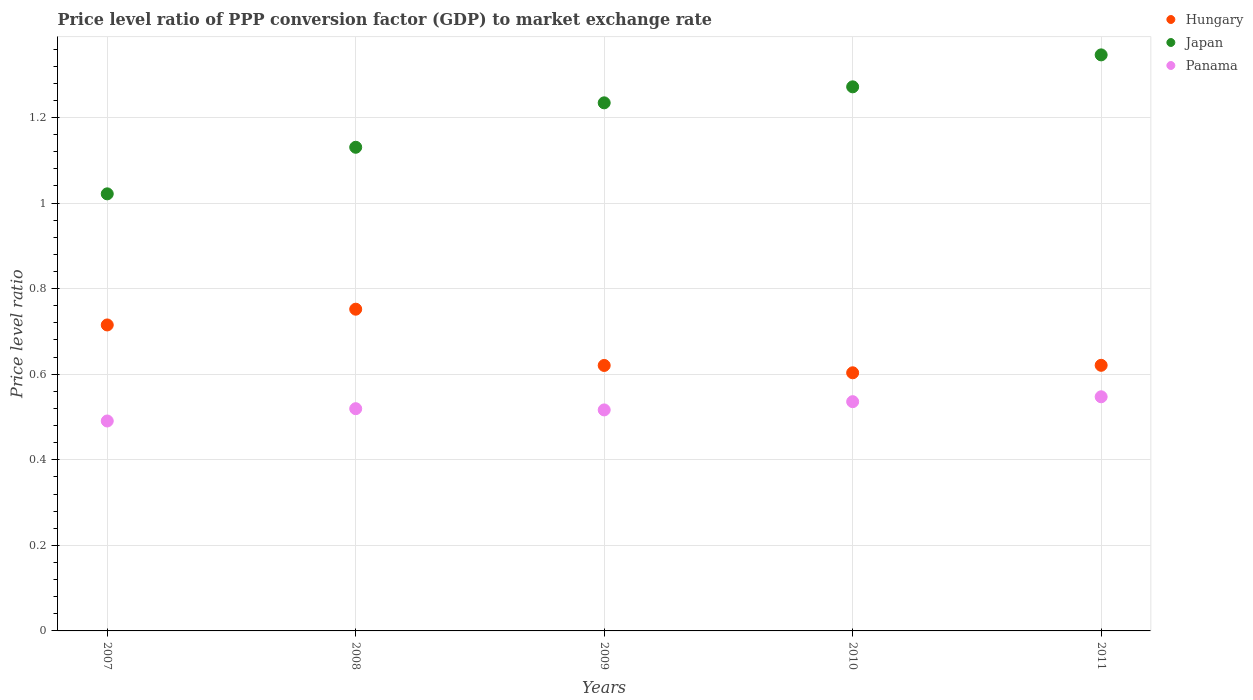What is the price level ratio in Panama in 2010?
Provide a short and direct response. 0.54. Across all years, what is the maximum price level ratio in Japan?
Offer a terse response. 1.35. Across all years, what is the minimum price level ratio in Panama?
Make the answer very short. 0.49. In which year was the price level ratio in Panama maximum?
Offer a very short reply. 2011. What is the total price level ratio in Panama in the graph?
Provide a short and direct response. 2.61. What is the difference between the price level ratio in Panama in 2007 and that in 2011?
Provide a short and direct response. -0.06. What is the difference between the price level ratio in Panama in 2011 and the price level ratio in Japan in 2008?
Make the answer very short. -0.58. What is the average price level ratio in Hungary per year?
Provide a short and direct response. 0.66. In the year 2010, what is the difference between the price level ratio in Panama and price level ratio in Japan?
Provide a short and direct response. -0.74. What is the ratio of the price level ratio in Panama in 2007 to that in 2009?
Provide a succinct answer. 0.95. What is the difference between the highest and the second highest price level ratio in Panama?
Make the answer very short. 0.01. What is the difference between the highest and the lowest price level ratio in Japan?
Offer a terse response. 0.32. Does the price level ratio in Panama monotonically increase over the years?
Ensure brevity in your answer.  No. How many dotlines are there?
Offer a terse response. 3. What is the difference between two consecutive major ticks on the Y-axis?
Ensure brevity in your answer.  0.2. Does the graph contain grids?
Provide a short and direct response. Yes. Where does the legend appear in the graph?
Your answer should be compact. Top right. How many legend labels are there?
Your answer should be compact. 3. How are the legend labels stacked?
Offer a terse response. Vertical. What is the title of the graph?
Keep it short and to the point. Price level ratio of PPP conversion factor (GDP) to market exchange rate. Does "Gabon" appear as one of the legend labels in the graph?
Offer a very short reply. No. What is the label or title of the X-axis?
Offer a terse response. Years. What is the label or title of the Y-axis?
Your answer should be very brief. Price level ratio. What is the Price level ratio of Hungary in 2007?
Ensure brevity in your answer.  0.72. What is the Price level ratio of Japan in 2007?
Make the answer very short. 1.02. What is the Price level ratio of Panama in 2007?
Make the answer very short. 0.49. What is the Price level ratio in Hungary in 2008?
Offer a terse response. 0.75. What is the Price level ratio of Japan in 2008?
Offer a very short reply. 1.13. What is the Price level ratio in Panama in 2008?
Give a very brief answer. 0.52. What is the Price level ratio of Hungary in 2009?
Provide a succinct answer. 0.62. What is the Price level ratio in Japan in 2009?
Your answer should be compact. 1.23. What is the Price level ratio in Panama in 2009?
Give a very brief answer. 0.52. What is the Price level ratio of Hungary in 2010?
Make the answer very short. 0.6. What is the Price level ratio of Japan in 2010?
Provide a succinct answer. 1.27. What is the Price level ratio of Panama in 2010?
Give a very brief answer. 0.54. What is the Price level ratio in Hungary in 2011?
Give a very brief answer. 0.62. What is the Price level ratio in Japan in 2011?
Your response must be concise. 1.35. What is the Price level ratio of Panama in 2011?
Make the answer very short. 0.55. Across all years, what is the maximum Price level ratio of Hungary?
Give a very brief answer. 0.75. Across all years, what is the maximum Price level ratio in Japan?
Offer a very short reply. 1.35. Across all years, what is the maximum Price level ratio of Panama?
Give a very brief answer. 0.55. Across all years, what is the minimum Price level ratio of Hungary?
Ensure brevity in your answer.  0.6. Across all years, what is the minimum Price level ratio of Japan?
Keep it short and to the point. 1.02. Across all years, what is the minimum Price level ratio of Panama?
Give a very brief answer. 0.49. What is the total Price level ratio of Hungary in the graph?
Make the answer very short. 3.31. What is the total Price level ratio in Japan in the graph?
Make the answer very short. 6. What is the total Price level ratio of Panama in the graph?
Offer a very short reply. 2.61. What is the difference between the Price level ratio of Hungary in 2007 and that in 2008?
Your response must be concise. -0.04. What is the difference between the Price level ratio of Japan in 2007 and that in 2008?
Offer a very short reply. -0.11. What is the difference between the Price level ratio in Panama in 2007 and that in 2008?
Provide a short and direct response. -0.03. What is the difference between the Price level ratio of Hungary in 2007 and that in 2009?
Provide a succinct answer. 0.09. What is the difference between the Price level ratio in Japan in 2007 and that in 2009?
Provide a short and direct response. -0.21. What is the difference between the Price level ratio of Panama in 2007 and that in 2009?
Your answer should be very brief. -0.03. What is the difference between the Price level ratio of Hungary in 2007 and that in 2010?
Your answer should be very brief. 0.11. What is the difference between the Price level ratio in Japan in 2007 and that in 2010?
Keep it short and to the point. -0.25. What is the difference between the Price level ratio of Panama in 2007 and that in 2010?
Your response must be concise. -0.05. What is the difference between the Price level ratio in Hungary in 2007 and that in 2011?
Your answer should be compact. 0.09. What is the difference between the Price level ratio in Japan in 2007 and that in 2011?
Offer a very short reply. -0.32. What is the difference between the Price level ratio of Panama in 2007 and that in 2011?
Provide a short and direct response. -0.06. What is the difference between the Price level ratio of Hungary in 2008 and that in 2009?
Make the answer very short. 0.13. What is the difference between the Price level ratio of Japan in 2008 and that in 2009?
Offer a terse response. -0.1. What is the difference between the Price level ratio of Panama in 2008 and that in 2009?
Provide a short and direct response. 0. What is the difference between the Price level ratio in Hungary in 2008 and that in 2010?
Keep it short and to the point. 0.15. What is the difference between the Price level ratio in Japan in 2008 and that in 2010?
Offer a very short reply. -0.14. What is the difference between the Price level ratio of Panama in 2008 and that in 2010?
Ensure brevity in your answer.  -0.02. What is the difference between the Price level ratio of Hungary in 2008 and that in 2011?
Your answer should be very brief. 0.13. What is the difference between the Price level ratio in Japan in 2008 and that in 2011?
Make the answer very short. -0.22. What is the difference between the Price level ratio in Panama in 2008 and that in 2011?
Your answer should be very brief. -0.03. What is the difference between the Price level ratio of Hungary in 2009 and that in 2010?
Your answer should be very brief. 0.02. What is the difference between the Price level ratio of Japan in 2009 and that in 2010?
Provide a short and direct response. -0.04. What is the difference between the Price level ratio of Panama in 2009 and that in 2010?
Provide a short and direct response. -0.02. What is the difference between the Price level ratio in Hungary in 2009 and that in 2011?
Provide a succinct answer. -0. What is the difference between the Price level ratio of Japan in 2009 and that in 2011?
Offer a very short reply. -0.11. What is the difference between the Price level ratio in Panama in 2009 and that in 2011?
Provide a succinct answer. -0.03. What is the difference between the Price level ratio in Hungary in 2010 and that in 2011?
Your answer should be compact. -0.02. What is the difference between the Price level ratio of Japan in 2010 and that in 2011?
Your answer should be very brief. -0.07. What is the difference between the Price level ratio of Panama in 2010 and that in 2011?
Your response must be concise. -0.01. What is the difference between the Price level ratio in Hungary in 2007 and the Price level ratio in Japan in 2008?
Offer a very short reply. -0.42. What is the difference between the Price level ratio in Hungary in 2007 and the Price level ratio in Panama in 2008?
Offer a very short reply. 0.2. What is the difference between the Price level ratio of Japan in 2007 and the Price level ratio of Panama in 2008?
Offer a terse response. 0.5. What is the difference between the Price level ratio in Hungary in 2007 and the Price level ratio in Japan in 2009?
Keep it short and to the point. -0.52. What is the difference between the Price level ratio in Hungary in 2007 and the Price level ratio in Panama in 2009?
Your response must be concise. 0.2. What is the difference between the Price level ratio of Japan in 2007 and the Price level ratio of Panama in 2009?
Provide a short and direct response. 0.51. What is the difference between the Price level ratio of Hungary in 2007 and the Price level ratio of Japan in 2010?
Offer a very short reply. -0.56. What is the difference between the Price level ratio of Hungary in 2007 and the Price level ratio of Panama in 2010?
Your answer should be compact. 0.18. What is the difference between the Price level ratio of Japan in 2007 and the Price level ratio of Panama in 2010?
Provide a succinct answer. 0.49. What is the difference between the Price level ratio of Hungary in 2007 and the Price level ratio of Japan in 2011?
Keep it short and to the point. -0.63. What is the difference between the Price level ratio in Hungary in 2007 and the Price level ratio in Panama in 2011?
Make the answer very short. 0.17. What is the difference between the Price level ratio of Japan in 2007 and the Price level ratio of Panama in 2011?
Offer a terse response. 0.47. What is the difference between the Price level ratio of Hungary in 2008 and the Price level ratio of Japan in 2009?
Offer a very short reply. -0.48. What is the difference between the Price level ratio of Hungary in 2008 and the Price level ratio of Panama in 2009?
Offer a terse response. 0.24. What is the difference between the Price level ratio in Japan in 2008 and the Price level ratio in Panama in 2009?
Make the answer very short. 0.61. What is the difference between the Price level ratio in Hungary in 2008 and the Price level ratio in Japan in 2010?
Provide a short and direct response. -0.52. What is the difference between the Price level ratio in Hungary in 2008 and the Price level ratio in Panama in 2010?
Keep it short and to the point. 0.22. What is the difference between the Price level ratio in Japan in 2008 and the Price level ratio in Panama in 2010?
Your answer should be compact. 0.59. What is the difference between the Price level ratio in Hungary in 2008 and the Price level ratio in Japan in 2011?
Keep it short and to the point. -0.59. What is the difference between the Price level ratio in Hungary in 2008 and the Price level ratio in Panama in 2011?
Offer a very short reply. 0.2. What is the difference between the Price level ratio in Japan in 2008 and the Price level ratio in Panama in 2011?
Your response must be concise. 0.58. What is the difference between the Price level ratio of Hungary in 2009 and the Price level ratio of Japan in 2010?
Keep it short and to the point. -0.65. What is the difference between the Price level ratio of Hungary in 2009 and the Price level ratio of Panama in 2010?
Make the answer very short. 0.08. What is the difference between the Price level ratio of Japan in 2009 and the Price level ratio of Panama in 2010?
Your response must be concise. 0.7. What is the difference between the Price level ratio in Hungary in 2009 and the Price level ratio in Japan in 2011?
Offer a terse response. -0.73. What is the difference between the Price level ratio in Hungary in 2009 and the Price level ratio in Panama in 2011?
Offer a very short reply. 0.07. What is the difference between the Price level ratio of Japan in 2009 and the Price level ratio of Panama in 2011?
Your answer should be very brief. 0.69. What is the difference between the Price level ratio in Hungary in 2010 and the Price level ratio in Japan in 2011?
Ensure brevity in your answer.  -0.74. What is the difference between the Price level ratio in Hungary in 2010 and the Price level ratio in Panama in 2011?
Your answer should be very brief. 0.06. What is the difference between the Price level ratio of Japan in 2010 and the Price level ratio of Panama in 2011?
Keep it short and to the point. 0.72. What is the average Price level ratio of Hungary per year?
Make the answer very short. 0.66. What is the average Price level ratio in Japan per year?
Provide a succinct answer. 1.2. What is the average Price level ratio in Panama per year?
Your answer should be very brief. 0.52. In the year 2007, what is the difference between the Price level ratio in Hungary and Price level ratio in Japan?
Offer a very short reply. -0.31. In the year 2007, what is the difference between the Price level ratio of Hungary and Price level ratio of Panama?
Provide a short and direct response. 0.22. In the year 2007, what is the difference between the Price level ratio in Japan and Price level ratio in Panama?
Offer a very short reply. 0.53. In the year 2008, what is the difference between the Price level ratio in Hungary and Price level ratio in Japan?
Your answer should be compact. -0.38. In the year 2008, what is the difference between the Price level ratio in Hungary and Price level ratio in Panama?
Your answer should be compact. 0.23. In the year 2008, what is the difference between the Price level ratio in Japan and Price level ratio in Panama?
Ensure brevity in your answer.  0.61. In the year 2009, what is the difference between the Price level ratio of Hungary and Price level ratio of Japan?
Offer a terse response. -0.61. In the year 2009, what is the difference between the Price level ratio of Hungary and Price level ratio of Panama?
Provide a short and direct response. 0.1. In the year 2009, what is the difference between the Price level ratio in Japan and Price level ratio in Panama?
Provide a short and direct response. 0.72. In the year 2010, what is the difference between the Price level ratio in Hungary and Price level ratio in Japan?
Provide a short and direct response. -0.67. In the year 2010, what is the difference between the Price level ratio in Hungary and Price level ratio in Panama?
Offer a terse response. 0.07. In the year 2010, what is the difference between the Price level ratio of Japan and Price level ratio of Panama?
Provide a short and direct response. 0.74. In the year 2011, what is the difference between the Price level ratio in Hungary and Price level ratio in Japan?
Make the answer very short. -0.73. In the year 2011, what is the difference between the Price level ratio of Hungary and Price level ratio of Panama?
Your response must be concise. 0.07. In the year 2011, what is the difference between the Price level ratio in Japan and Price level ratio in Panama?
Provide a succinct answer. 0.8. What is the ratio of the Price level ratio of Hungary in 2007 to that in 2008?
Your answer should be compact. 0.95. What is the ratio of the Price level ratio in Japan in 2007 to that in 2008?
Your response must be concise. 0.9. What is the ratio of the Price level ratio in Panama in 2007 to that in 2008?
Your answer should be very brief. 0.94. What is the ratio of the Price level ratio of Hungary in 2007 to that in 2009?
Provide a short and direct response. 1.15. What is the ratio of the Price level ratio of Japan in 2007 to that in 2009?
Offer a very short reply. 0.83. What is the ratio of the Price level ratio of Panama in 2007 to that in 2009?
Your answer should be compact. 0.95. What is the ratio of the Price level ratio of Hungary in 2007 to that in 2010?
Your response must be concise. 1.19. What is the ratio of the Price level ratio in Japan in 2007 to that in 2010?
Ensure brevity in your answer.  0.8. What is the ratio of the Price level ratio of Panama in 2007 to that in 2010?
Ensure brevity in your answer.  0.92. What is the ratio of the Price level ratio of Hungary in 2007 to that in 2011?
Your answer should be very brief. 1.15. What is the ratio of the Price level ratio of Japan in 2007 to that in 2011?
Your answer should be very brief. 0.76. What is the ratio of the Price level ratio of Panama in 2007 to that in 2011?
Your answer should be compact. 0.9. What is the ratio of the Price level ratio in Hungary in 2008 to that in 2009?
Keep it short and to the point. 1.21. What is the ratio of the Price level ratio of Japan in 2008 to that in 2009?
Ensure brevity in your answer.  0.92. What is the ratio of the Price level ratio in Panama in 2008 to that in 2009?
Make the answer very short. 1.01. What is the ratio of the Price level ratio in Hungary in 2008 to that in 2010?
Your answer should be very brief. 1.25. What is the ratio of the Price level ratio in Japan in 2008 to that in 2010?
Make the answer very short. 0.89. What is the ratio of the Price level ratio in Panama in 2008 to that in 2010?
Your response must be concise. 0.97. What is the ratio of the Price level ratio in Hungary in 2008 to that in 2011?
Your answer should be compact. 1.21. What is the ratio of the Price level ratio in Japan in 2008 to that in 2011?
Your answer should be very brief. 0.84. What is the ratio of the Price level ratio in Panama in 2008 to that in 2011?
Provide a short and direct response. 0.95. What is the ratio of the Price level ratio of Hungary in 2009 to that in 2010?
Ensure brevity in your answer.  1.03. What is the ratio of the Price level ratio in Japan in 2009 to that in 2010?
Offer a very short reply. 0.97. What is the ratio of the Price level ratio in Panama in 2009 to that in 2010?
Keep it short and to the point. 0.96. What is the ratio of the Price level ratio in Hungary in 2009 to that in 2011?
Your answer should be compact. 1. What is the ratio of the Price level ratio in Panama in 2009 to that in 2011?
Your response must be concise. 0.94. What is the ratio of the Price level ratio of Hungary in 2010 to that in 2011?
Make the answer very short. 0.97. What is the ratio of the Price level ratio in Japan in 2010 to that in 2011?
Your response must be concise. 0.94. What is the ratio of the Price level ratio of Panama in 2010 to that in 2011?
Your answer should be compact. 0.98. What is the difference between the highest and the second highest Price level ratio in Hungary?
Give a very brief answer. 0.04. What is the difference between the highest and the second highest Price level ratio in Japan?
Ensure brevity in your answer.  0.07. What is the difference between the highest and the second highest Price level ratio of Panama?
Your answer should be very brief. 0.01. What is the difference between the highest and the lowest Price level ratio of Hungary?
Give a very brief answer. 0.15. What is the difference between the highest and the lowest Price level ratio in Japan?
Make the answer very short. 0.32. What is the difference between the highest and the lowest Price level ratio of Panama?
Provide a short and direct response. 0.06. 